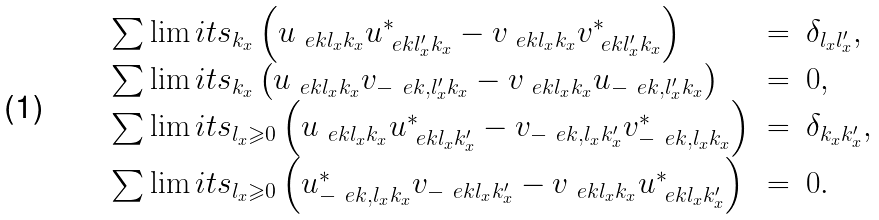<formula> <loc_0><loc_0><loc_500><loc_500>\begin{array} { l c l } \sum \lim i t s _ { k _ { x } } \left ( u _ { \ e k l _ { x } k _ { x } } u ^ { * } _ { \ e k l ^ { \prime } _ { x } k _ { x } } - v _ { \ e k l _ { x } k _ { x } } v ^ { * } _ { \ e k l ^ { \prime } _ { x } k _ { x } } \right ) & = & \delta _ { l _ { x } l ^ { \prime } _ { x } } , \\ \sum \lim i t s _ { k _ { x } } \left ( u _ { \ e k l _ { x } k _ { x } } v _ { - \ e k , l ^ { \prime } _ { x } k _ { x } } - v _ { \ e k l _ { x } k _ { x } } u _ { - \ e k , l ^ { \prime } _ { x } k _ { x } } \right ) & = & 0 , \\ \sum \lim i t s _ { l _ { x } \geqslant 0 } \left ( u _ { \ e k l _ { x } k _ { x } } u ^ { * } _ { \ e k l _ { x } k _ { x } ^ { \prime } } - v _ { - \ e k , l _ { x } k _ { x } ^ { \prime } } v ^ { * } _ { - \ e k , l _ { x } k _ { x } } \right ) & = & \delta _ { k _ { x } k _ { x } ^ { \prime } } , \\ \sum \lim i t s _ { l _ { x } \geqslant 0 } \left ( u ^ { * } _ { - \ e k , l _ { x } k _ { x } } v _ { - \ e k l _ { x } k _ { x } ^ { \prime } } - v _ { \ e k l _ { x } k _ { x } } u ^ { * } _ { \ e k l _ { x } k _ { x } ^ { \prime } } \right ) & = & 0 . \end{array}</formula> 